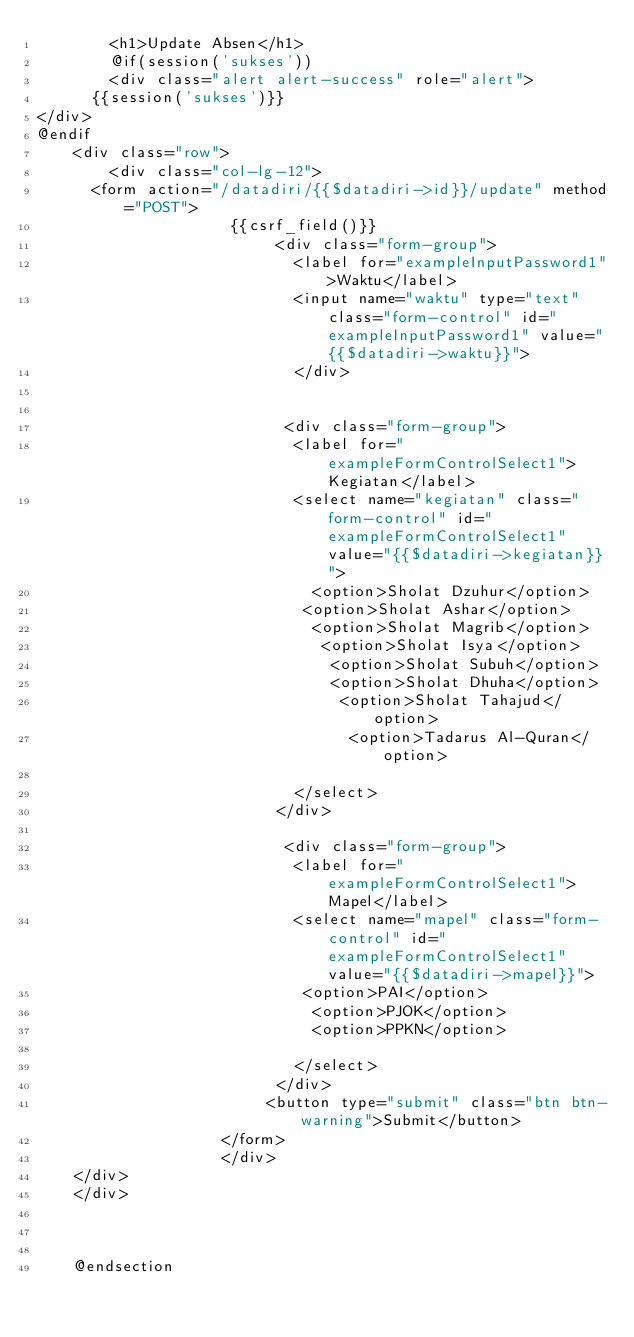<code> <loc_0><loc_0><loc_500><loc_500><_PHP_>		<h1>Update Absen</h1>
		@if(session('sukses'))
		<div class="alert alert-success" role="alert">
      {{session('sukses')}}
</div>
@endif
	<div class="row">
		<div class="col-lg-12">
	  <form action="/datadiri/{{$datadiri->id}}/update" method="POST">
					 {{csrf_field()}}
                          <div class="form-group">
                            <label for="exampleInputPassword1">Waktu</label>
                            <input name="waktu" type="text" class="form-control" id="exampleInputPassword1" value="{{$datadiri->waktu}}">
                            </div>

                             
						   <div class="form-group">
						    <label for="exampleFormControlSelect1">Kegiatan</label>
						    <select name="kegiatan" class="form-control" id="exampleFormControlSelect1" value="{{$datadiri->kegiatan}}">
						      <option>Sholat Dzuhur</option>
						     <option>Sholat Ashar</option>
						      <option>Sholat Magrib</option>
						       <option>Sholat Isya</option>
						        <option>Sholat Subuh</option>
						        <option>Sholat Dhuha</option>
						         <option>Sholat Tahajud</option>
						          <option>Tadarus Al-Quran</option>
						          
						    </select>
						  </div>

                           <div class="form-group">
						    <label for="exampleFormControlSelect1">Mapel</label>
						    <select name="mapel" class="form-control" id="exampleFormControlSelect1" value="{{$datadiri->mapel}}">
						     <option>PAI</option>
						      <option>PJOK</option>
						      <option>PPKN</option>
						     
						    </select>
						  </div>
						 <button type="submit" class="btn btn-warning">Submit</button>
			        </form>
					</div>
    </div>
	</div>
	
	

	@endsection</code> 